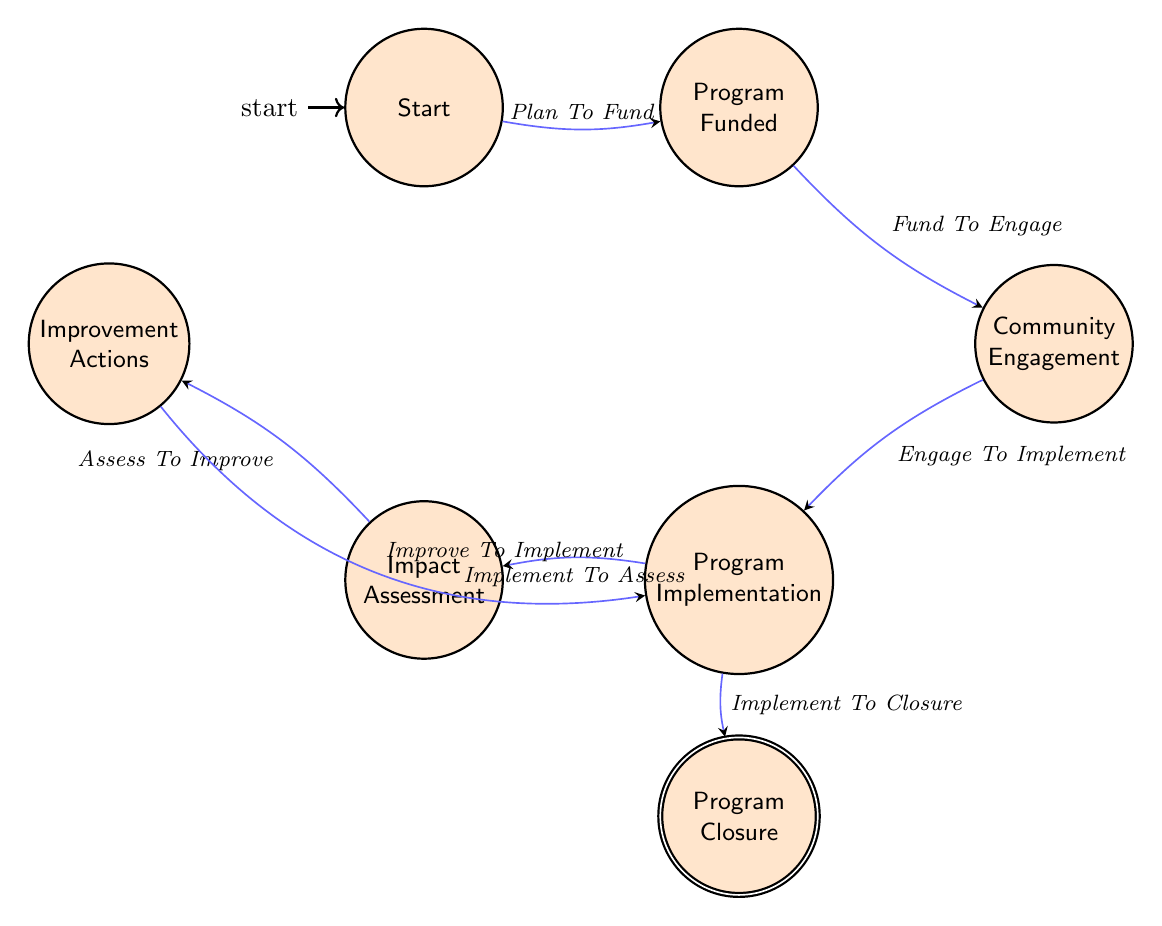What is the initial state in the diagram? The diagram starts with the state labeled "Start," which represents the planning phase of a sports program.
Answer: Start How many states are there in the diagram? By counting the states listed, there are a total of 7 states represented in the diagram.
Answer: 7 What transition occurs from the "Program Implementation" state? From the "Program Implementation" state, there are two possible transitions: "Implement To Assess" and "Implement To Closure."
Answer: Implement To Assess, Implement To Closure What is the state reached after "Fund To Engage"? Following the transition "Fund To Engage," the next state reached is "Community Engagement," where the program interacts with the community.
Answer: Community Engagement Which transition leads to "Improvement Actions"? The transition "Assess To Improve" leads directly to the state of "Improvement Actions," which is focused on modifying the program based on feedback.
Answer: Assess To Improve What is the final state of the program as illustrated in this diagram? The final state, at which the sports program concludes, is labeled "Program Closure." This indicates the end of the operational phase and the generation of final reports.
Answer: Program Closure What is the relationship between "Impact Assessment" and "Improvement Actions"? "Impact Assessment" transitions to "Improvement Actions" through the transition labeled "Assess To Improve," signifying the process of evaluating impacts and implementing changes.
Answer: Assess To Improve From which state does the program begin engaging with the community? The program begins engaging with the community from the "Program Funded" state after the funding has been secured.
Answer: Program Funded 